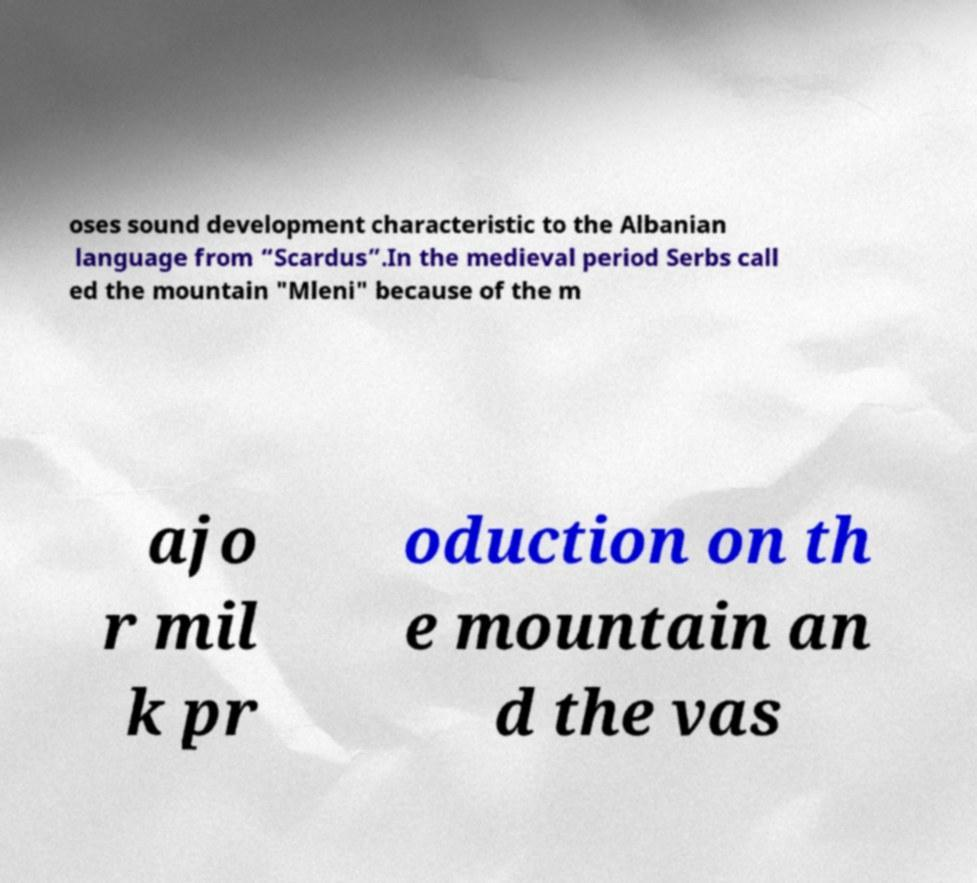Can you accurately transcribe the text from the provided image for me? oses sound development characteristic to the Albanian language from “Scardus”.In the medieval period Serbs call ed the mountain "Mleni" because of the m ajo r mil k pr oduction on th e mountain an d the vas 